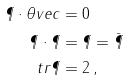<formula> <loc_0><loc_0><loc_500><loc_500>\P \cdot \theta v e c & = 0 \\ \P \cdot \P & = \P = \bar { \P } \\ t r \P & = 2 \, ,</formula> 